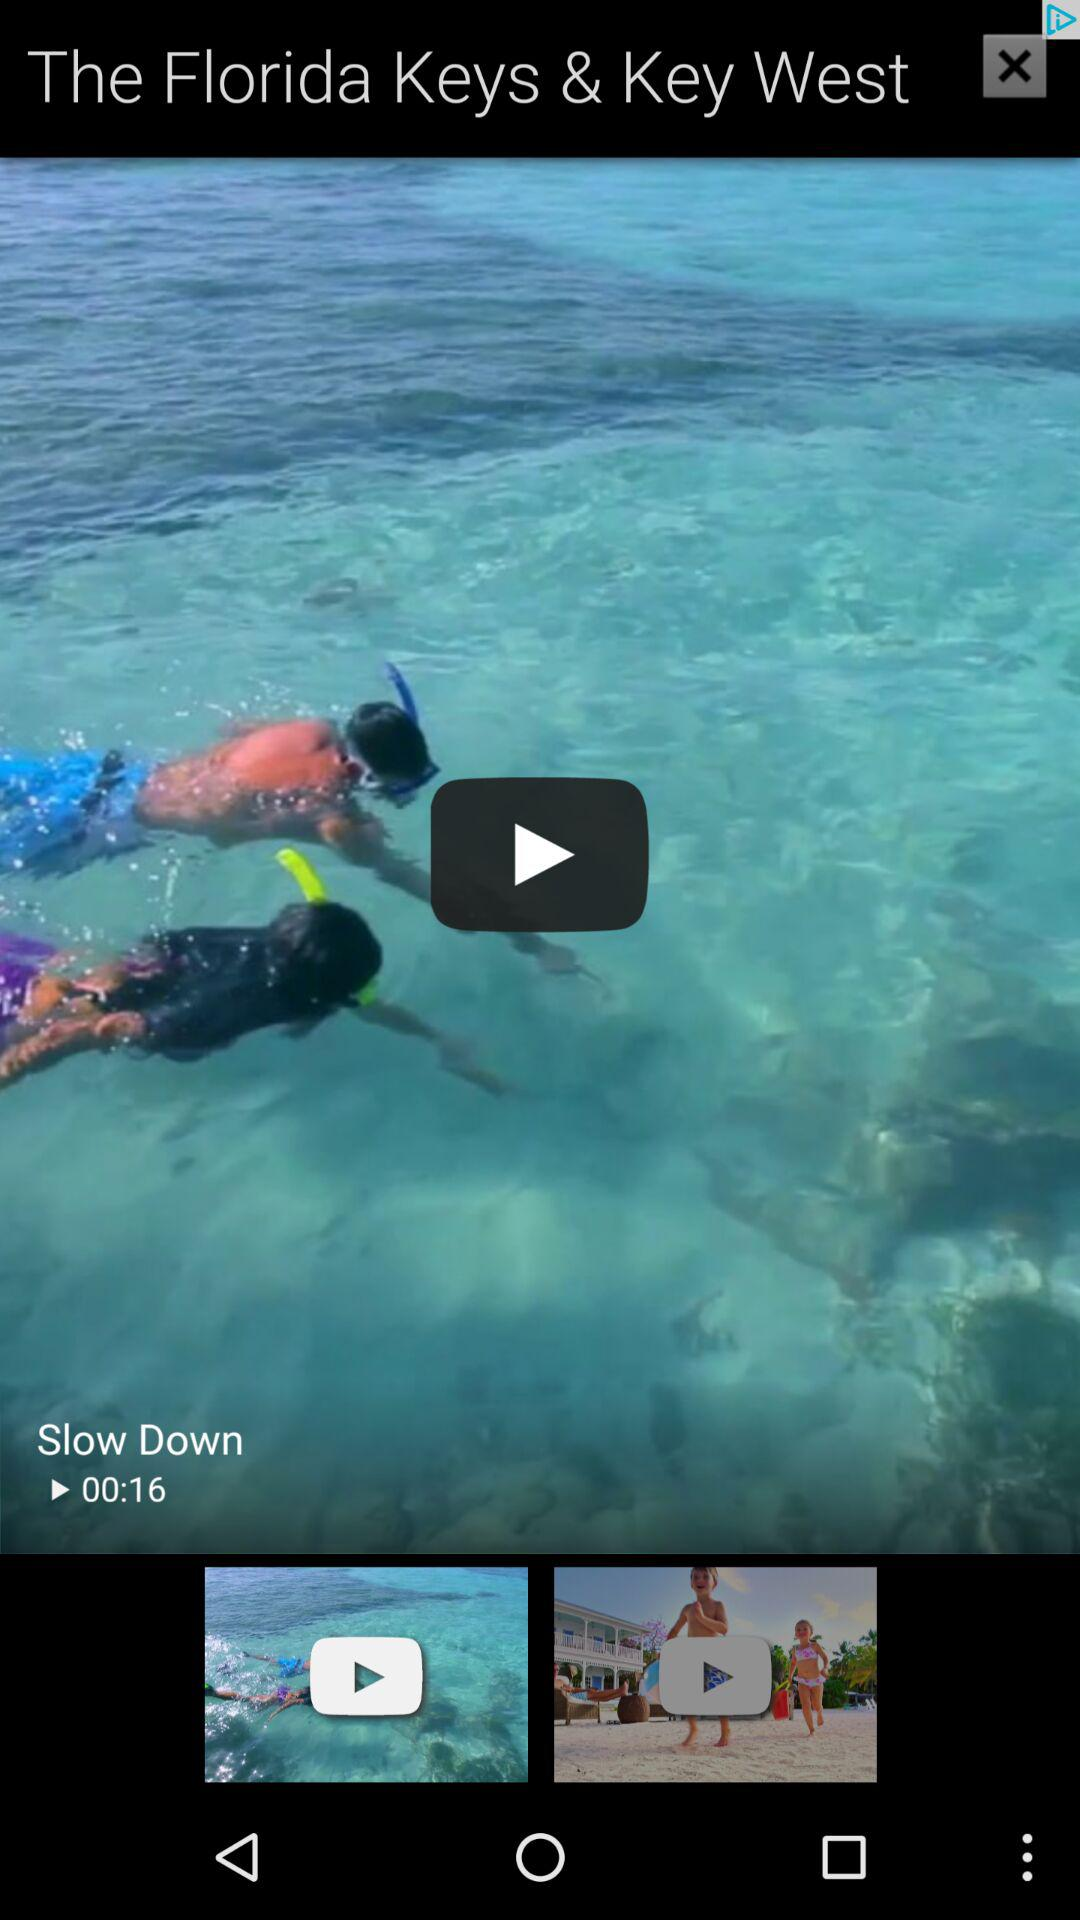How many seconds long is the video with the text 'Slow Down'?
Answer the question using a single word or phrase. 16 